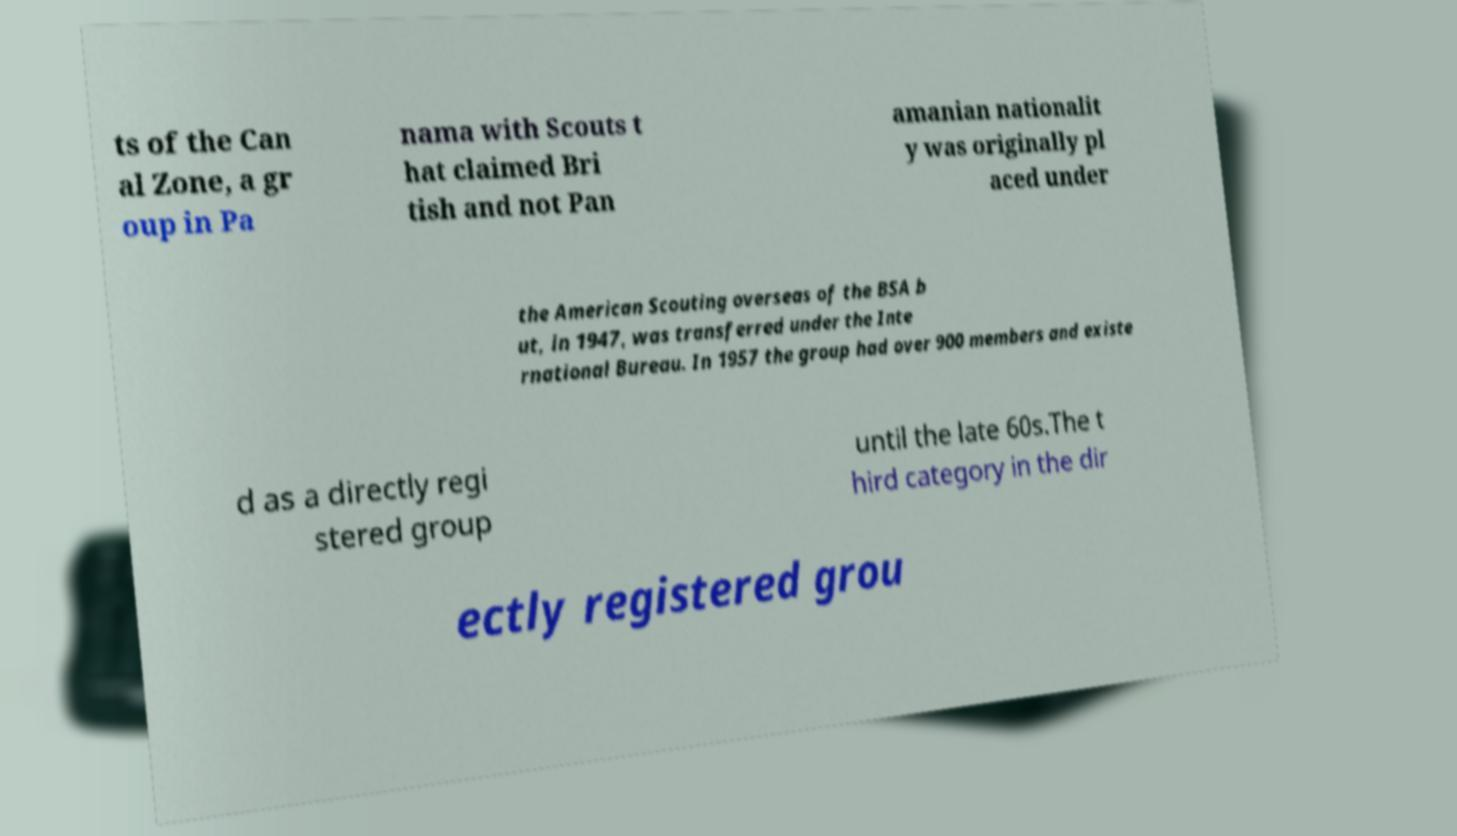Can you read and provide the text displayed in the image?This photo seems to have some interesting text. Can you extract and type it out for me? ts of the Can al Zone, a gr oup in Pa nama with Scouts t hat claimed Bri tish and not Pan amanian nationalit y was originally pl aced under the American Scouting overseas of the BSA b ut, in 1947, was transferred under the Inte rnational Bureau. In 1957 the group had over 900 members and existe d as a directly regi stered group until the late 60s.The t hird category in the dir ectly registered grou 